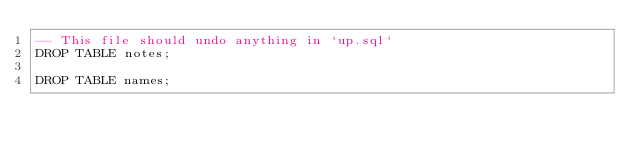<code> <loc_0><loc_0><loc_500><loc_500><_SQL_>-- This file should undo anything in `up.sql`
DROP TABLE notes;

DROP TABLE names;
</code> 